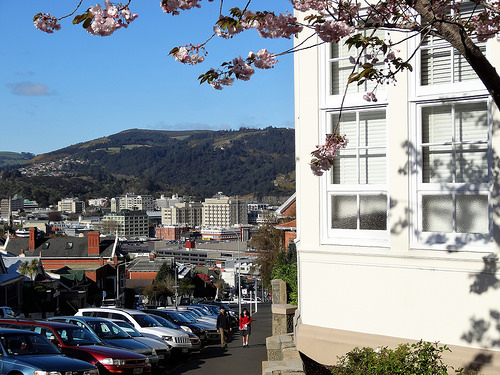<image>
Can you confirm if the branch is on the building? No. The branch is not positioned on the building. They may be near each other, but the branch is not supported by or resting on top of the building. 